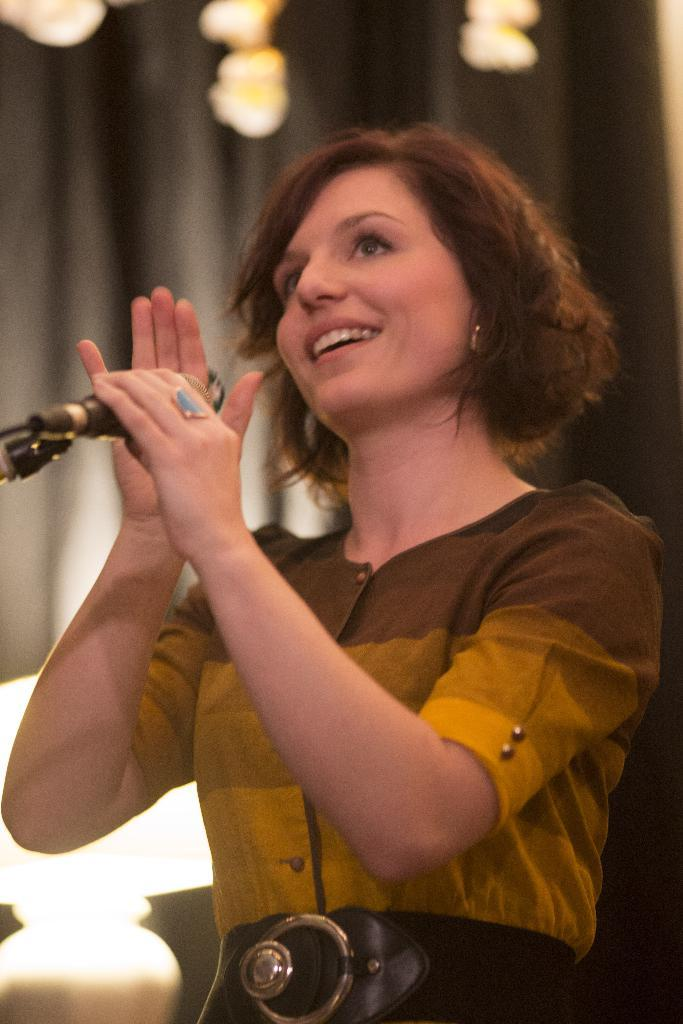What is the person in the image doing? The person is standing in the image and holding a microphone. What is the person's facial expression in the image? The person is smiling in the image. What can be seen in the background of the image? There is a curtain and lights in the background of the image. What type of book is the person reading in the image? There is no book present in the image; the person is holding a microphone and standing. What kind of hat is the person wearing in the image? There is no hat present in the image; the person is not wearing any headgear. 